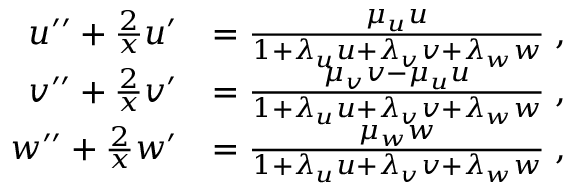<formula> <loc_0><loc_0><loc_500><loc_500>\begin{array} { r l } { u ^ { \prime \prime } + \frac { 2 } { x } u ^ { \prime } } & { = \frac { \mu _ { u } u } { 1 + \lambda _ { u } u + \lambda _ { v } v + \lambda _ { w } w } \, , } \\ { v ^ { \prime \prime } + \frac { 2 } { x } v ^ { \prime } } & { = \frac { \mu _ { v } v - \mu _ { u } u } { 1 + \lambda _ { u } u + \lambda _ { v } v + \lambda _ { w } w } \, , } \\ { w ^ { \prime \prime } + \frac { 2 } { x } w ^ { \prime } } & { = \frac { \mu _ { w } w } { 1 + \lambda _ { u } u + \lambda _ { v } v + \lambda _ { w } w } \, , } \end{array}</formula> 